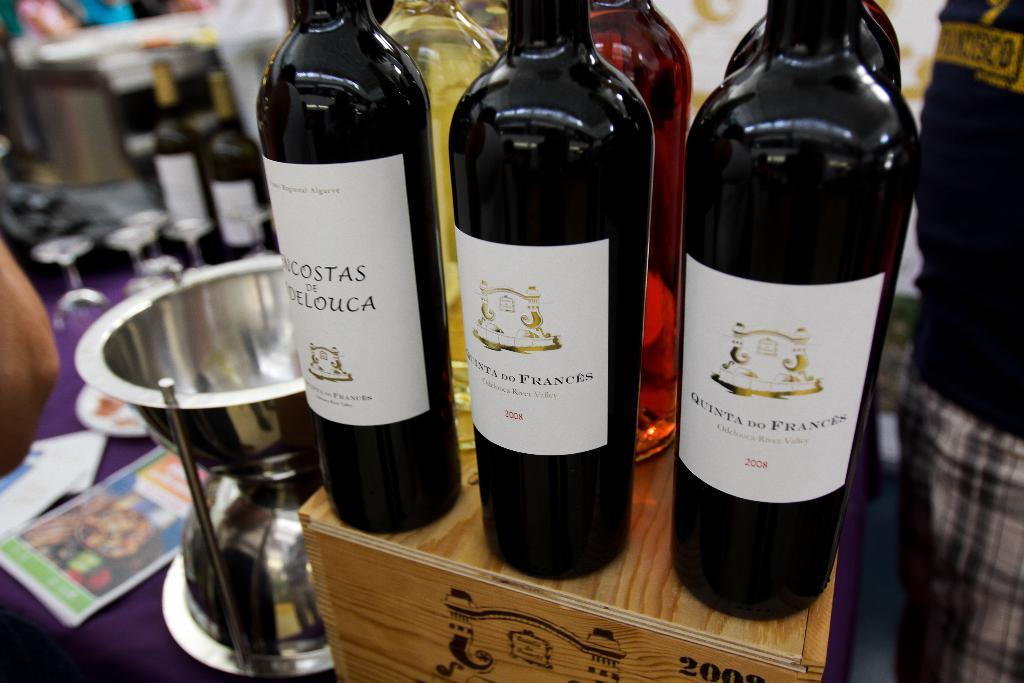<image>
Write a terse but informative summary of the picture. Three bottles of wine are next to each other, including two from 2008. 